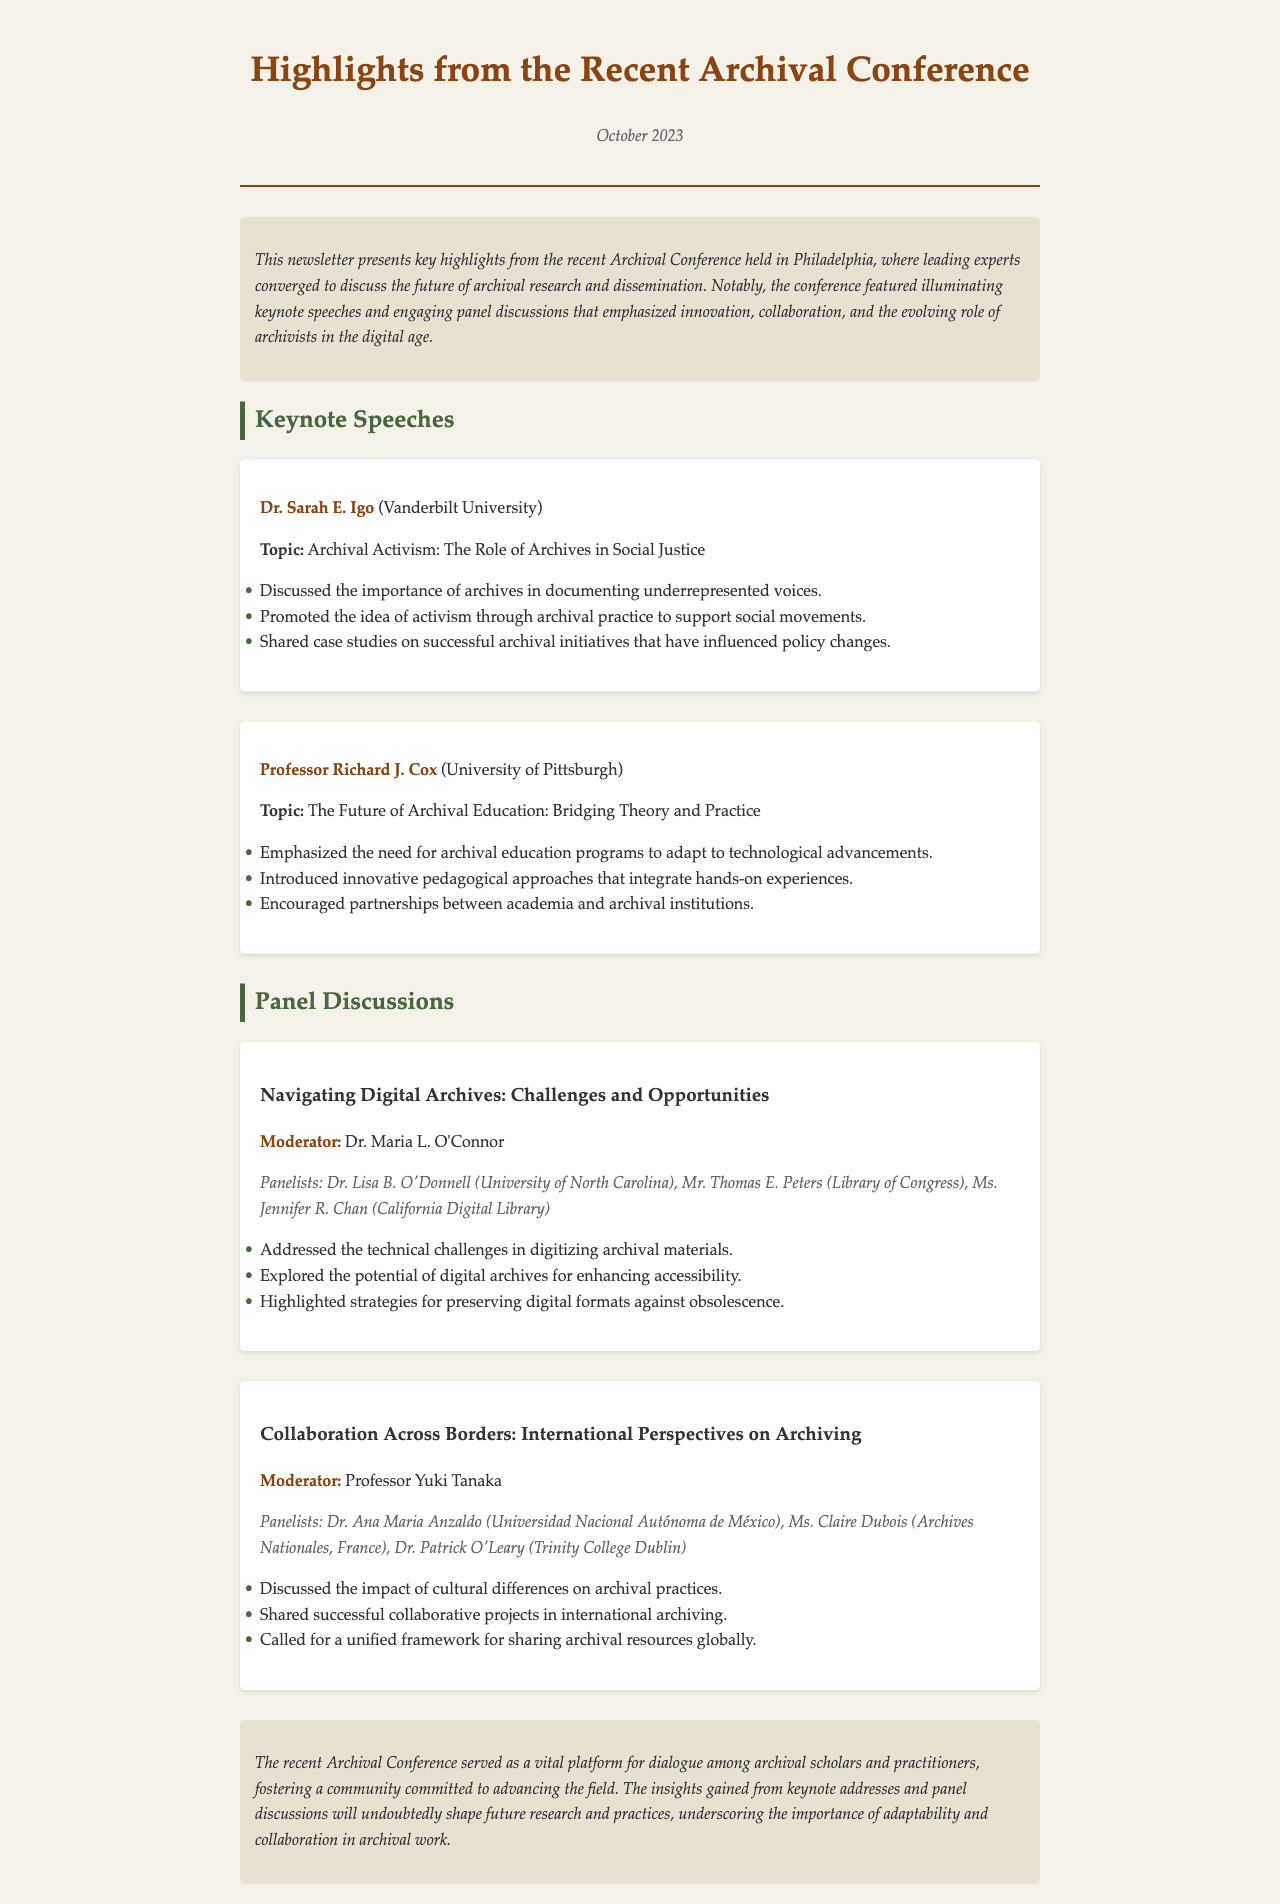What is the date of the newsletter? The date of the newsletter is mentioned at the top as October 2023.
Answer: October 2023 Who was the speaker discussing Archival Activism? The speaker on Archival Activism was Dr. Sarah E. Igo from Vanderbilt University.
Answer: Dr. Sarah E. Igo What topic did Professor Richard J. Cox cover? Professor Richard J. Cox covered the topic of the future of archival education.
Answer: The Future of Archival Education: Bridging Theory and Practice Who moderated the panel discussion on Digital Archives? The moderator for the panel discussion on Digital Archives was Dr. Maria L. O'Connor.
Answer: Dr. Maria L. O'Connor How many panelists were listed for the discussion on Collaboration Across Borders? There were three panelists listed for the discussion on Collaboration Across Borders.
Answer: Three What does the conclusion of the newsletter highlight as important for future research? The conclusion emphasizes the importance of adaptability and collaboration in archival work for future research.
Answer: Adaptability and collaboration What is a key topic discussed in the panel about Digital Archives? A key topic discussed in the Digital Archives panel was the technical challenges in digitizing archival materials.
Answer: Technical challenges in digitizing archival materials What key concept did Dr. Igo promote in her speech? Dr. Igo promoted the idea of activism through archival practice to support social movements.
Answer: Activism through archival practice 